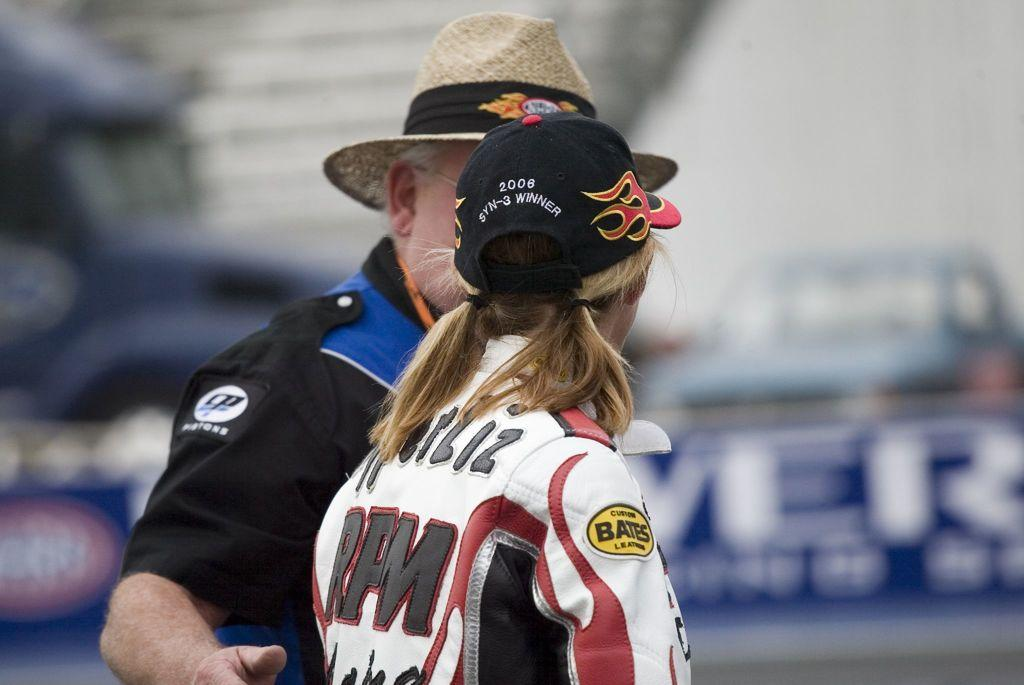<image>
Create a compact narrative representing the image presented. a person that has the word Bates on their arm 